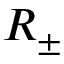<formula> <loc_0><loc_0><loc_500><loc_500>R _ { \pm }</formula> 